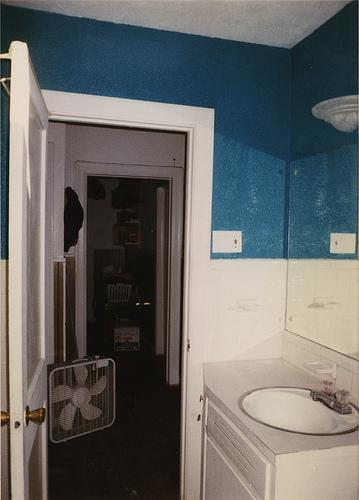Describe any visible objects or features that are typically seen in a bathroom. A white bathroom sink, silver faucet, mirror, light switches, cabinets under the sink, soap dish, and tiles on the wall above the sink. Examine the reflection in the mirror. What can be seen in it? A reflection of a light fixture can be seen in the mirror. Comment on the state of the sink in the image. The sink is clean, white, and has a metal ring around it. Narrate a brief description of the image focusing on the most noticeable objects and colors. The bathroom has blue painted walls and features an open white door, a white sink with a silver faucet, a large mirror on the wall, white cabinets, and a white box fan on the floor. There is also a white laundry basket in the room and a garment hanging on the wall. How many fans are present in the image? Describe their appearance and location. There is one fan present in the image. It is a square-shaped white box fan positioned on the floor. List all visible objects in the room. box fan, faucet knobs, doorknob, door, wall paint, mirror, reflection, door frame, light switches, bathroom wall, sink, soap holder, bathroom door handles, garment on wall, cabinets, electrical outlet, cupboard under sink, tiles, large mirror, door handle, laundry basket, floor, strike plate, sink, tile backsplash, bathroom countertop, metal ring around sink, bathroom sink, reflection of light fixture, wall trim, basket of clothes, box under table, jacket on the wall. What material covers the bathroom floor? The floor appears to be a dark-colored material, perhaps tile or wood. Analyze the emotional ambiance of the image. The image depicts a clean and organized bathroom, giving a sense of calm and orderliness. However, the open door leading to a dark room adds a slight element of mystery or intrigue. What type of room is displayed in the image? A bathroom. Identify the primary color scheme in the image. Blue and white are the predominant colors in this image, with blue on the walls and white on the door, sink, and various other objects. What action is taking place in the room, if any? No current activity. Identify the color of the wall in the bathroom. Blue. What would you conclude about the room based on the mirror? The mirror reflects the light fixture and door. Explain the components of the bathroom setup shown in the diagram. The bathroom has a sink, a faucet, a mirror, and a box fan on the floor. Where is the small mirror on the wall? The mirror mentioned in the image is large, not small. So the instruction is misleading. Please read the words or numbers visible in the image. No visible text. Provide a brief description of the door in the image. The door is white and open with a gold doorknob. Create a short story based on the image. Once upon a time, in a small house with blue walls, there was a bathroom where a couple getting ready for a party had left the door open and a box fan on the floor. Describe the object placed on the wall above the sink. A mirror. What event seems to have occurred in the room? The door was opened. What is the color of the floor in the image? Dark. Provide a brief description of the light switches in the image. The light switches are on the wall and white. Is there a wooden doorknob on the bathroom door? No, it's not mentioned in the image. Can you see the red box fan on the floor? The instruction is misleading because there is a white box fan on the floor, not a red one. What is on the floor in the image? A box fan. Which statement is true about the faucet in the image? b) The faucet has two clear knobs. Is the door open or closed? The door is open. Where is the green paint on the wall? The wall is described as blue painted, not green. So the instruction is misleading. Create a poem based on the image. In a room of blue and white, Can you point out the plastic faucet hanging over the sink? The faucets mentioned in the image are silver and not described as plastic. So the instruction is misleading. Describe an interesting detail about the image in adjective-noun form. Blue bathroom wall. Describe the scene in the image using vivid language. A quaint bathroom with blue walls, a white sink, a mirror, and a box fan on the floor. What color is the laundry basket in the room? White. Can you find the black laundry basket in the room? There is a white laundry basket mentioned in the image captions, not a black one. So the instruction is misleading. 